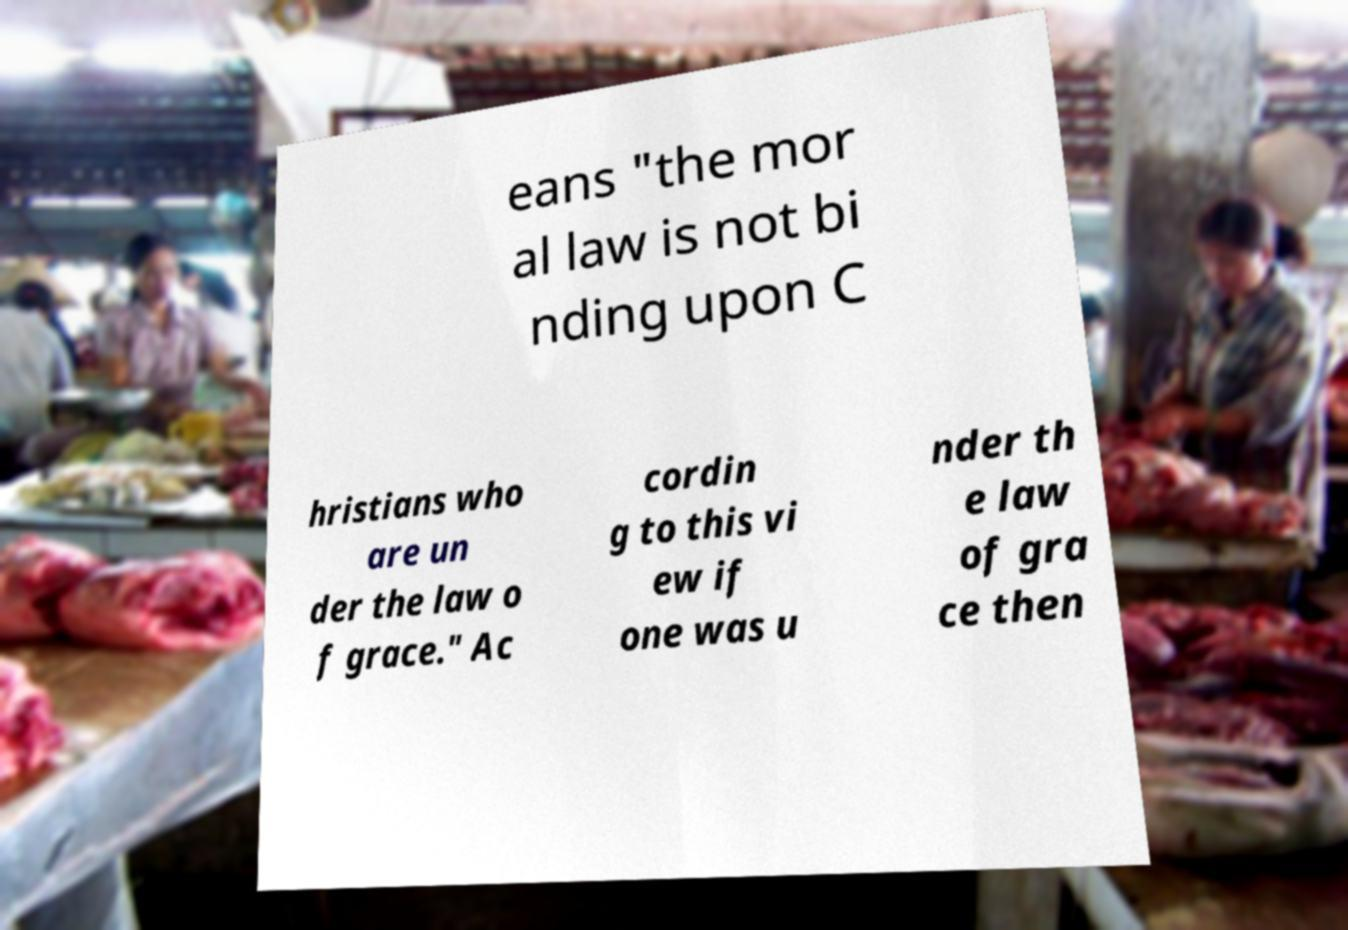Please read and relay the text visible in this image. What does it say? eans "the mor al law is not bi nding upon C hristians who are un der the law o f grace." Ac cordin g to this vi ew if one was u nder th e law of gra ce then 